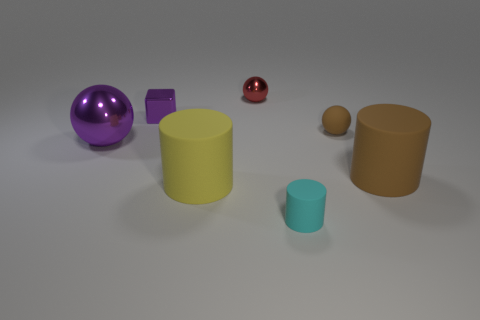Add 1 gray rubber objects. How many objects exist? 8 Subtract all cylinders. How many objects are left? 4 Subtract 1 brown balls. How many objects are left? 6 Subtract all large purple things. Subtract all purple shiny balls. How many objects are left? 5 Add 5 tiny brown things. How many tiny brown things are left? 6 Add 7 large purple balls. How many large purple balls exist? 8 